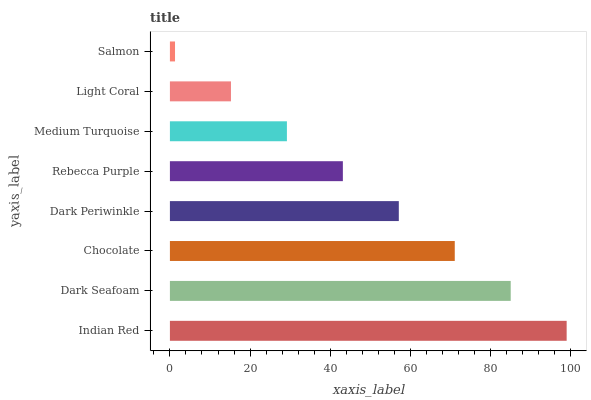Is Salmon the minimum?
Answer yes or no. Yes. Is Indian Red the maximum?
Answer yes or no. Yes. Is Dark Seafoam the minimum?
Answer yes or no. No. Is Dark Seafoam the maximum?
Answer yes or no. No. Is Indian Red greater than Dark Seafoam?
Answer yes or no. Yes. Is Dark Seafoam less than Indian Red?
Answer yes or no. Yes. Is Dark Seafoam greater than Indian Red?
Answer yes or no. No. Is Indian Red less than Dark Seafoam?
Answer yes or no. No. Is Dark Periwinkle the high median?
Answer yes or no. Yes. Is Rebecca Purple the low median?
Answer yes or no. Yes. Is Medium Turquoise the high median?
Answer yes or no. No. Is Chocolate the low median?
Answer yes or no. No. 